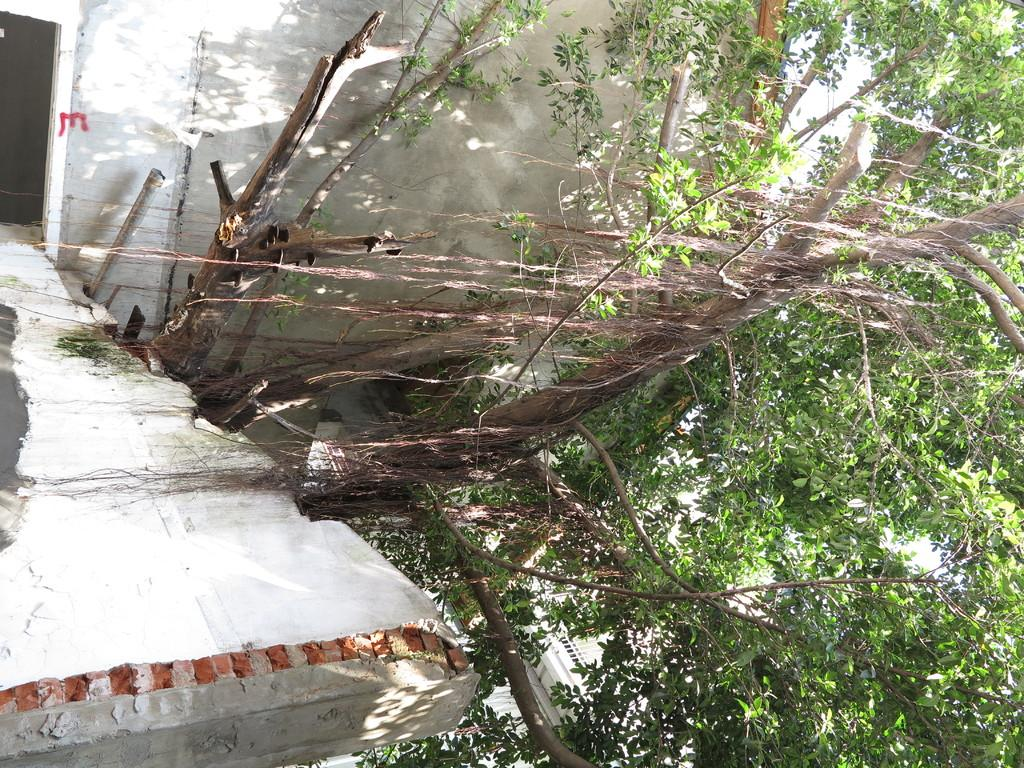What type of vegetation can be seen in the image? There are trees in the image. What color are the trees? The trees are green in color. What structure is visible in the background of the image? There is a building in the background of the image. What color is the building? The building is white in color. Can you tell me how many spoons are hanging from the trees in the image? There are no spoons present in the image; it features trees and a building. 